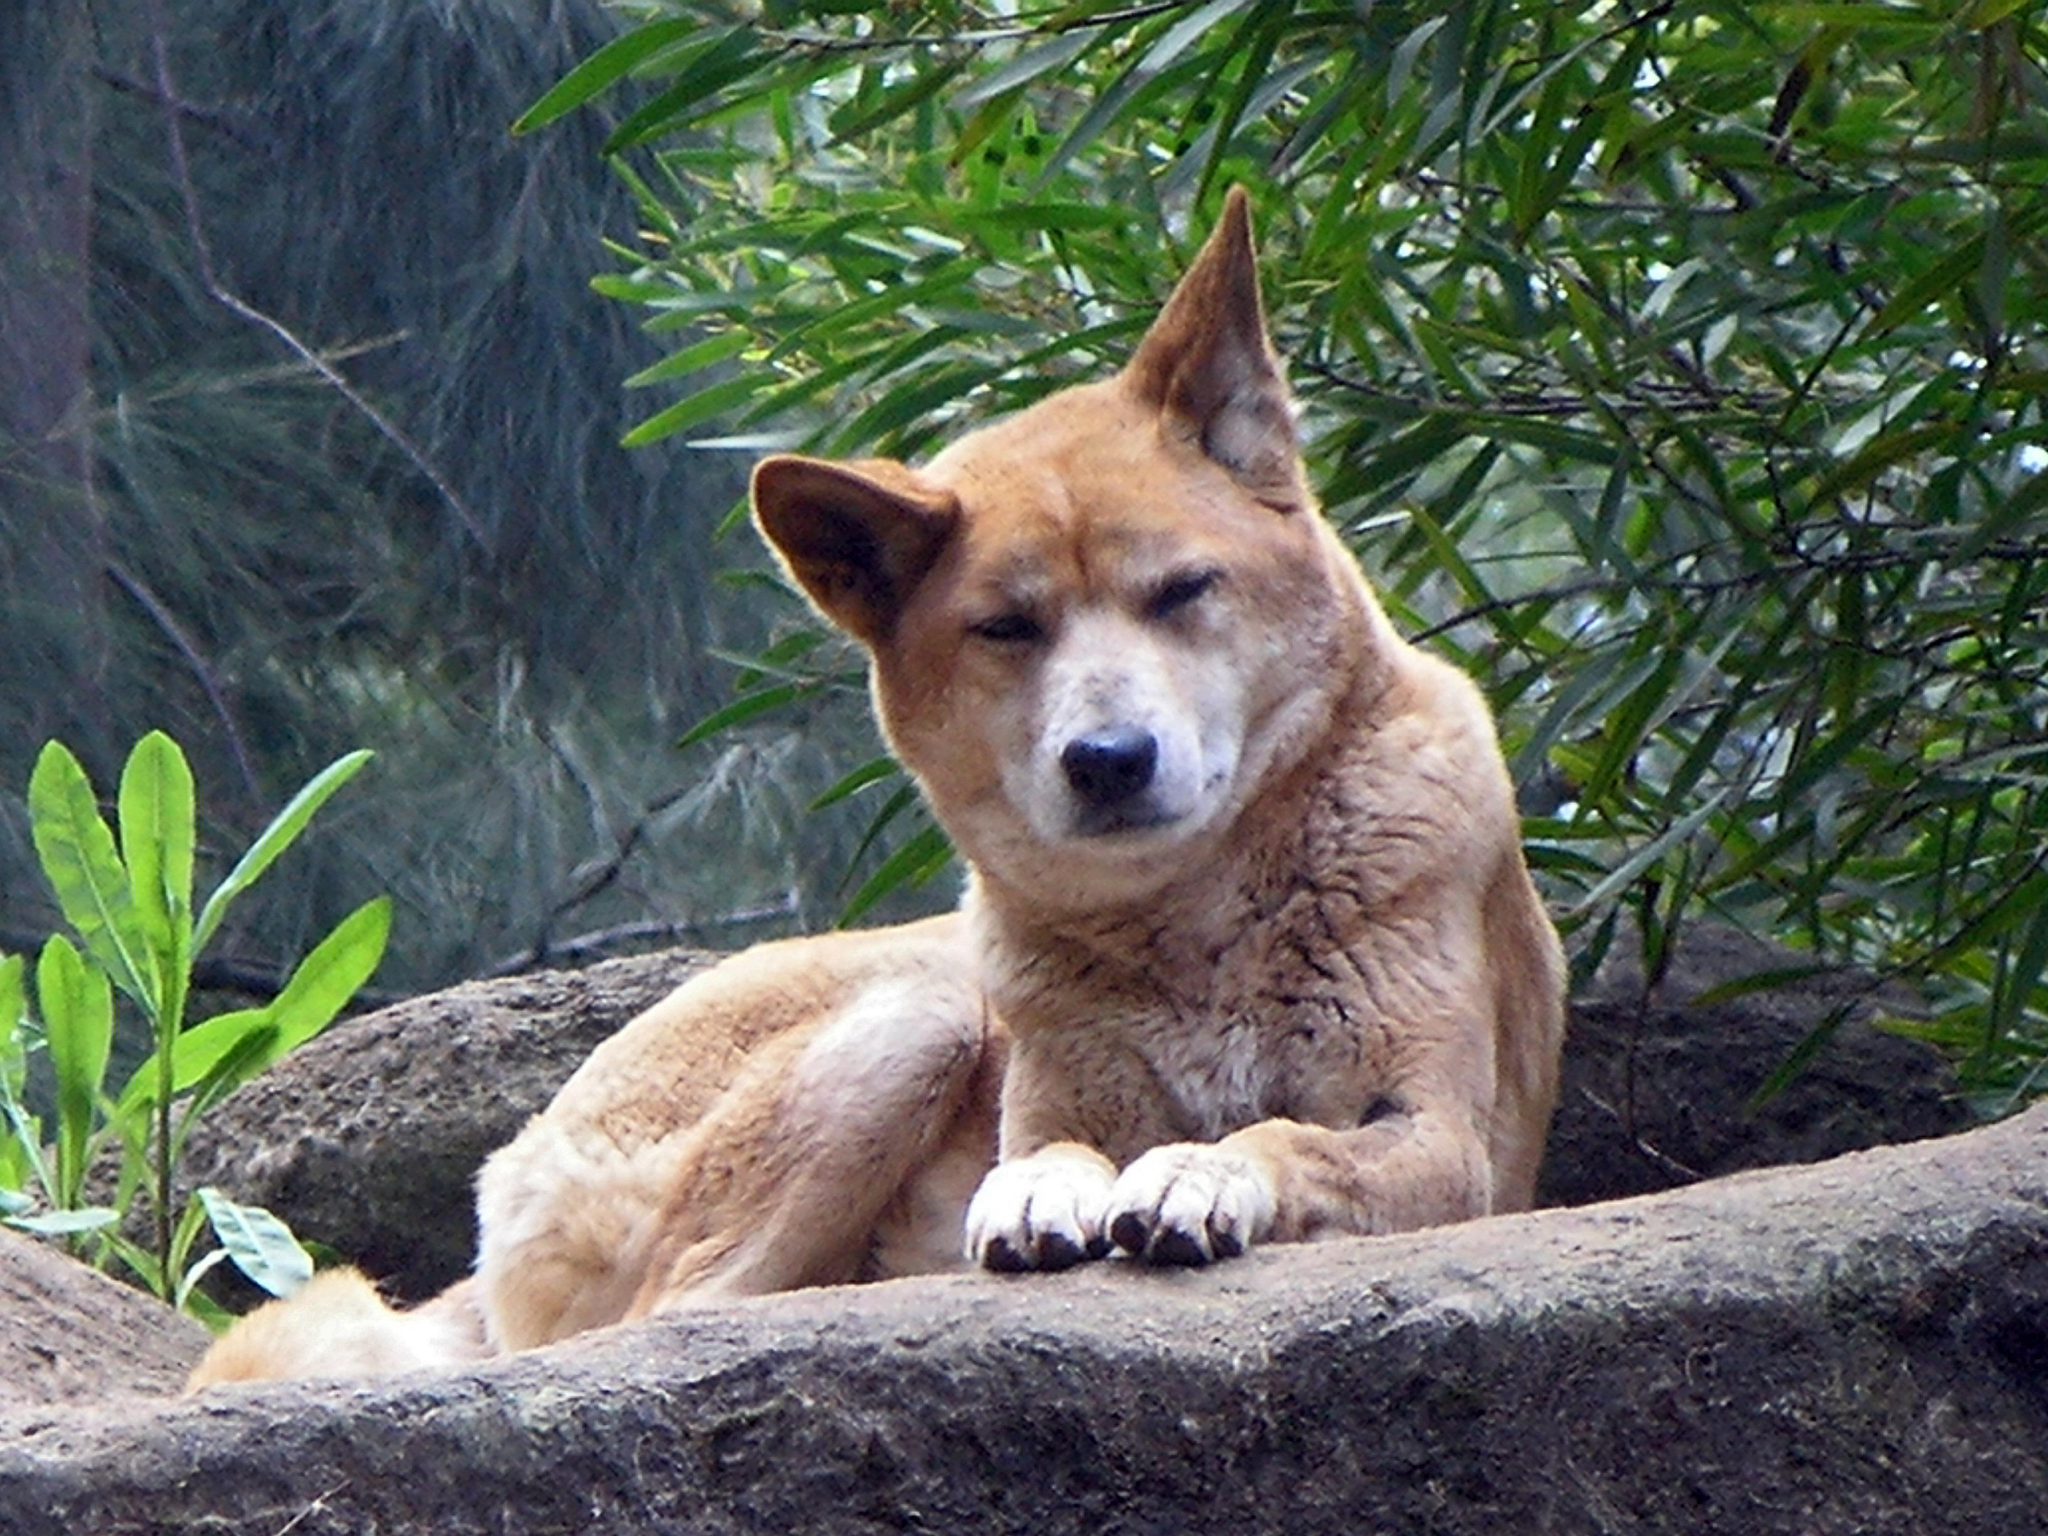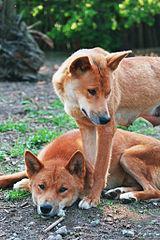The first image is the image on the left, the second image is the image on the right. For the images shown, is this caption "There are three dogs" true? Answer yes or no. Yes. 